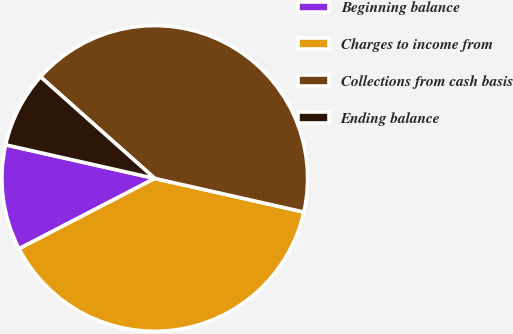Convert chart to OTSL. <chart><loc_0><loc_0><loc_500><loc_500><pie_chart><fcel>Beginning balance<fcel>Charges to income from<fcel>Collections from cash basis<fcel>Ending balance<nl><fcel>11.14%<fcel>38.86%<fcel>41.96%<fcel>8.04%<nl></chart> 